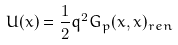<formula> <loc_0><loc_0><loc_500><loc_500>U ( x ) = \frac { 1 } { 2 } q ^ { 2 } G _ { p } ( x , x ) _ { r e n }</formula> 